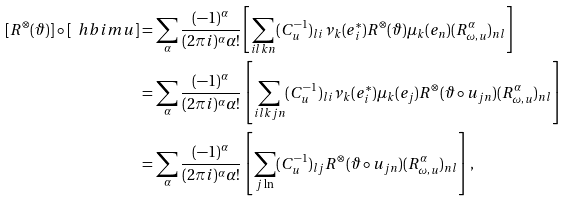<formula> <loc_0><loc_0><loc_500><loc_500>[ R ^ { \otimes } ( \vartheta ) ] \circ [ \ h b i m { u } ] & = \sum _ { \alpha } \frac { ( - 1 ) ^ { \alpha } } { ( 2 \pi i ) ^ { \alpha } \alpha ! } \left [ \sum _ { i l k n } ( C _ { u } ^ { - 1 } ) _ { l i } \nu _ { k } ( e _ { i } ^ { * } ) R ^ { \otimes } ( \vartheta ) \mu _ { k } ( e _ { n } ) ( R ^ { \alpha } _ { \omega , u } ) _ { n l } \right ] \\ & = \sum _ { \alpha } \frac { ( - 1 ) ^ { \alpha } } { ( 2 \pi i ) ^ { \alpha } \alpha ! } \left [ \sum _ { i l k j n } ( C _ { u } ^ { - 1 } ) _ { l i } \nu _ { k } ( e _ { i } ^ { * } ) \mu _ { k } ( e _ { j } ) R ^ { \otimes } ( \vartheta \circ u _ { j n } ) ( R ^ { \alpha } _ { \omega , u } ) _ { n l } \right ] \\ & = \sum _ { \alpha } \frac { ( - 1 ) ^ { \alpha } } { ( 2 \pi i ) ^ { \alpha } \alpha ! } \left [ \sum _ { j \ln } ( C _ { u } ^ { - 1 } ) _ { l j } R ^ { \otimes } ( \vartheta \circ u _ { j n } ) ( R ^ { \alpha } _ { \omega , u } ) _ { n l } \right ] ,</formula> 